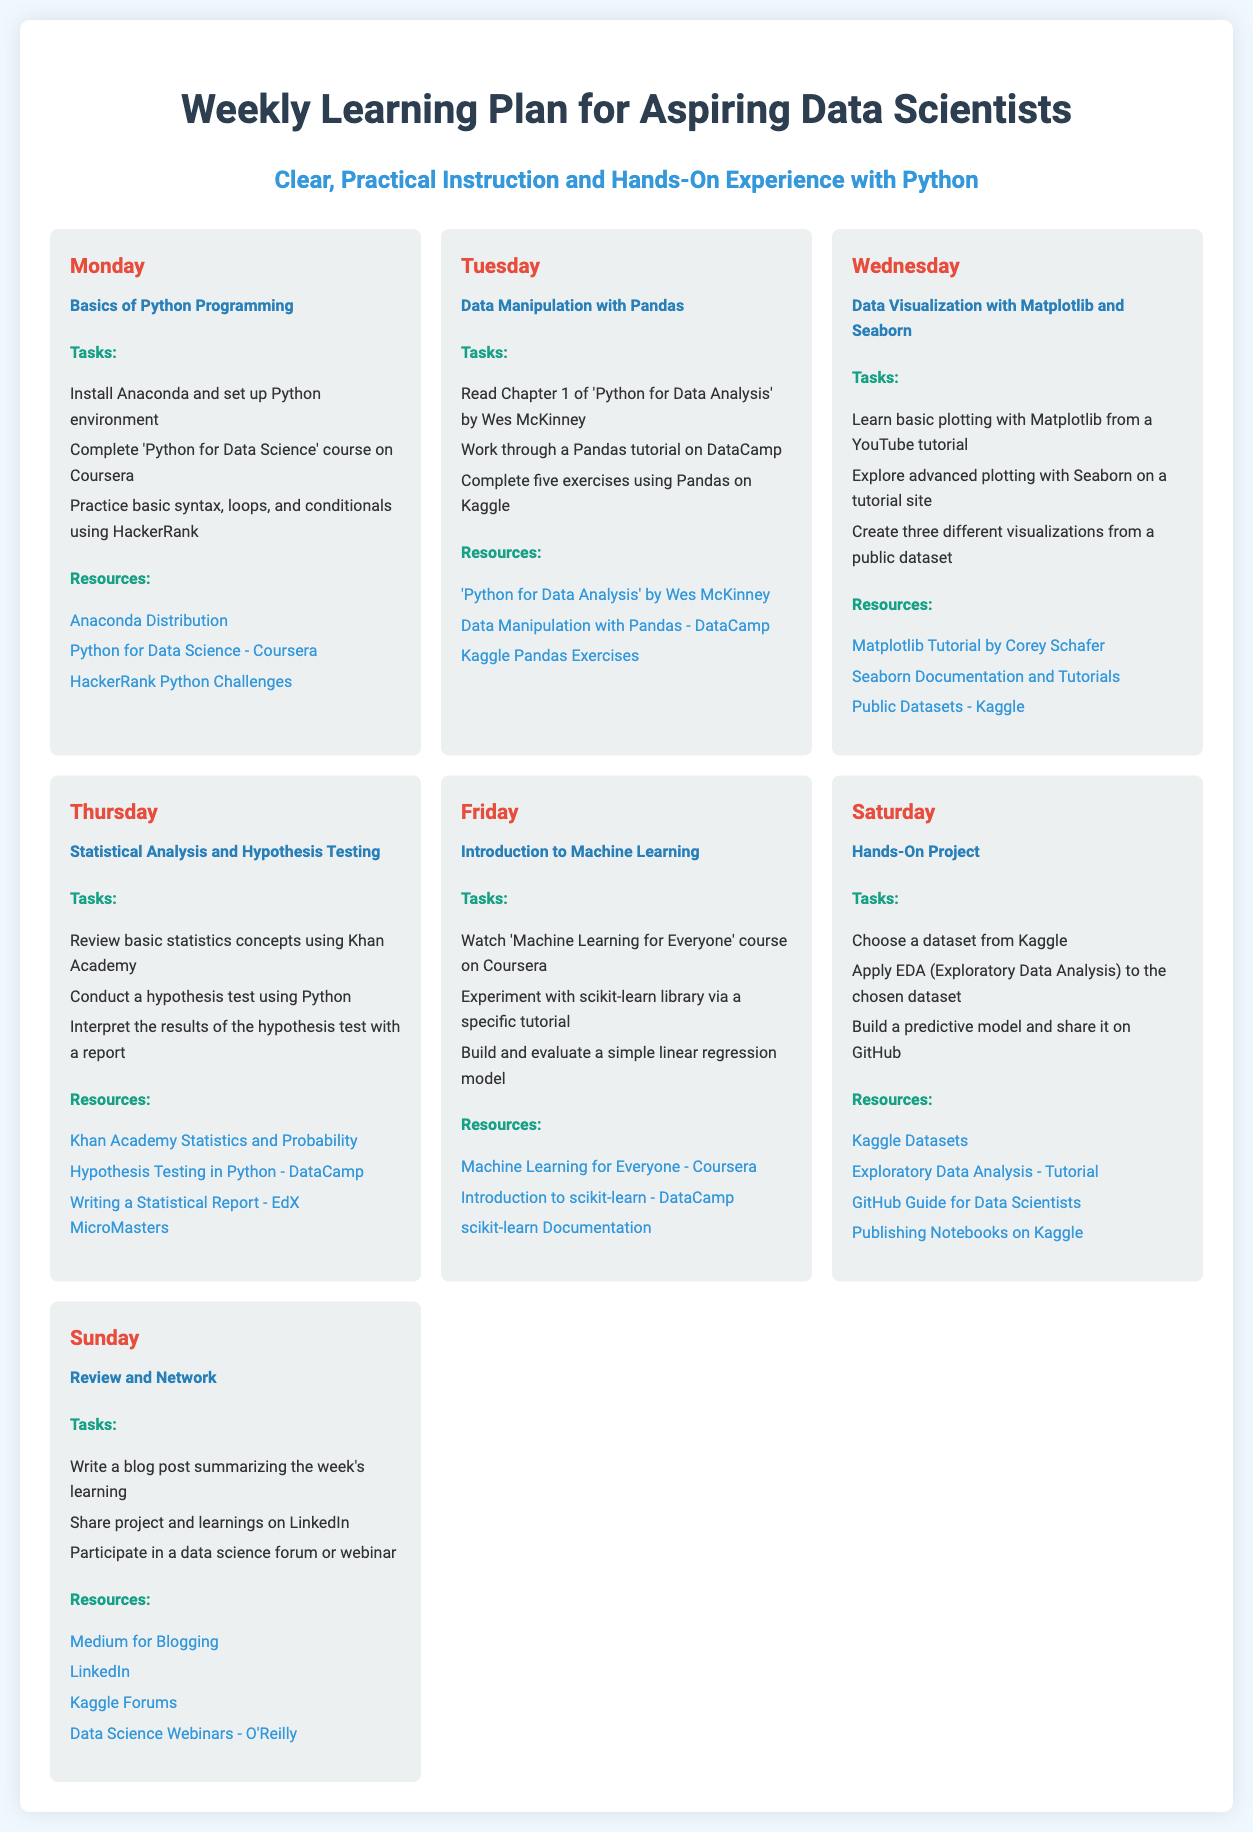What is the main topic of the infographic? The main topic highlighted in the infographic is the learning plan tailored for aspiring data scientists.
Answer: Weekly Learning Plan for Aspiring Data Scientists How many tasks are listed for Wednesday? The number of tasks listed for Wednesday is the total items in the tasks section for that day, which is three.
Answer: 3 Which resource is associated with Data Manipulation using Pandas? The resource for Data Manipulation with Pandas includes a course that provides related content for learning.
Answer: Data Manipulation with Pandas - DataCamp What day is dedicated to hands-on projects? The day specifically assigned for hands-on projects is clearly mentioned within the weekly structure of learning.
Answer: Saturday What is the learning focus for Thursday? Thursday's focus is specifically geared towards a significant concept crucial for data analysis and statistics.
Answer: Statistical Analysis and Hypothesis Testing How many days include tasks related to machine learning? By reviewing the weekly tasks, you can determine how many days focus on machine learning as a topic.
Answer: 1 What is the final task for Sunday? The task listed last for Sunday emphasizes a community aspect of data science and participation.
Answer: Participate in a data science forum or webinar What is the color theme of the document? The color theme incorporates specific color contrasts that enhance readability and aesthetics.
Answer: White and light colors with blue accents Which platform is suggested for sharing project learnings? The platform recommended for sharing work and connecting with professionals is a popular networking site.
Answer: LinkedIn 